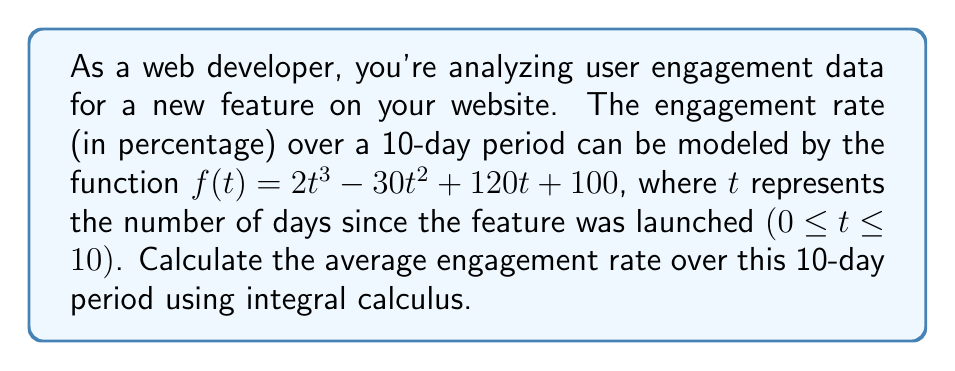Give your solution to this math problem. To solve this problem, we need to follow these steps:

1) The average value of a function $f(t)$ over an interval $[a, b]$ is given by:

   $$\text{Average} = \frac{1}{b-a} \int_a^b f(t) dt$$

2) In our case, $a=0$, $b=10$, and $f(t) = 2t^3 - 30t^2 + 120t + 100$. So we need to calculate:

   $$\text{Average} = \frac{1}{10} \int_0^{10} (2t^3 - 30t^2 + 120t + 100) dt$$

3) Let's integrate the function:

   $$\int (2t^3 - 30t^2 + 120t + 100) dt = \frac{1}{2}t^4 - 10t^3 + 60t^2 + 100t + C$$

4) Now, we need to evaluate this from 0 to 10:

   $$\left[\frac{1}{2}t^4 - 10t^3 + 60t^2 + 100t\right]_0^{10}$$

5) Plugging in the values:

   $$(\frac{1}{2}(10^4) - 10(10^3) + 60(10^2) + 100(10)) - (0)$$
   
   $$= 5000 - 10000 + 6000 + 1000 = 2000$$

6) Finally, we divide by the interval length (10) to get the average:

   $$\text{Average} = \frac{2000}{10} = 200$$
Answer: The average engagement rate over the 10-day period is 200%. 